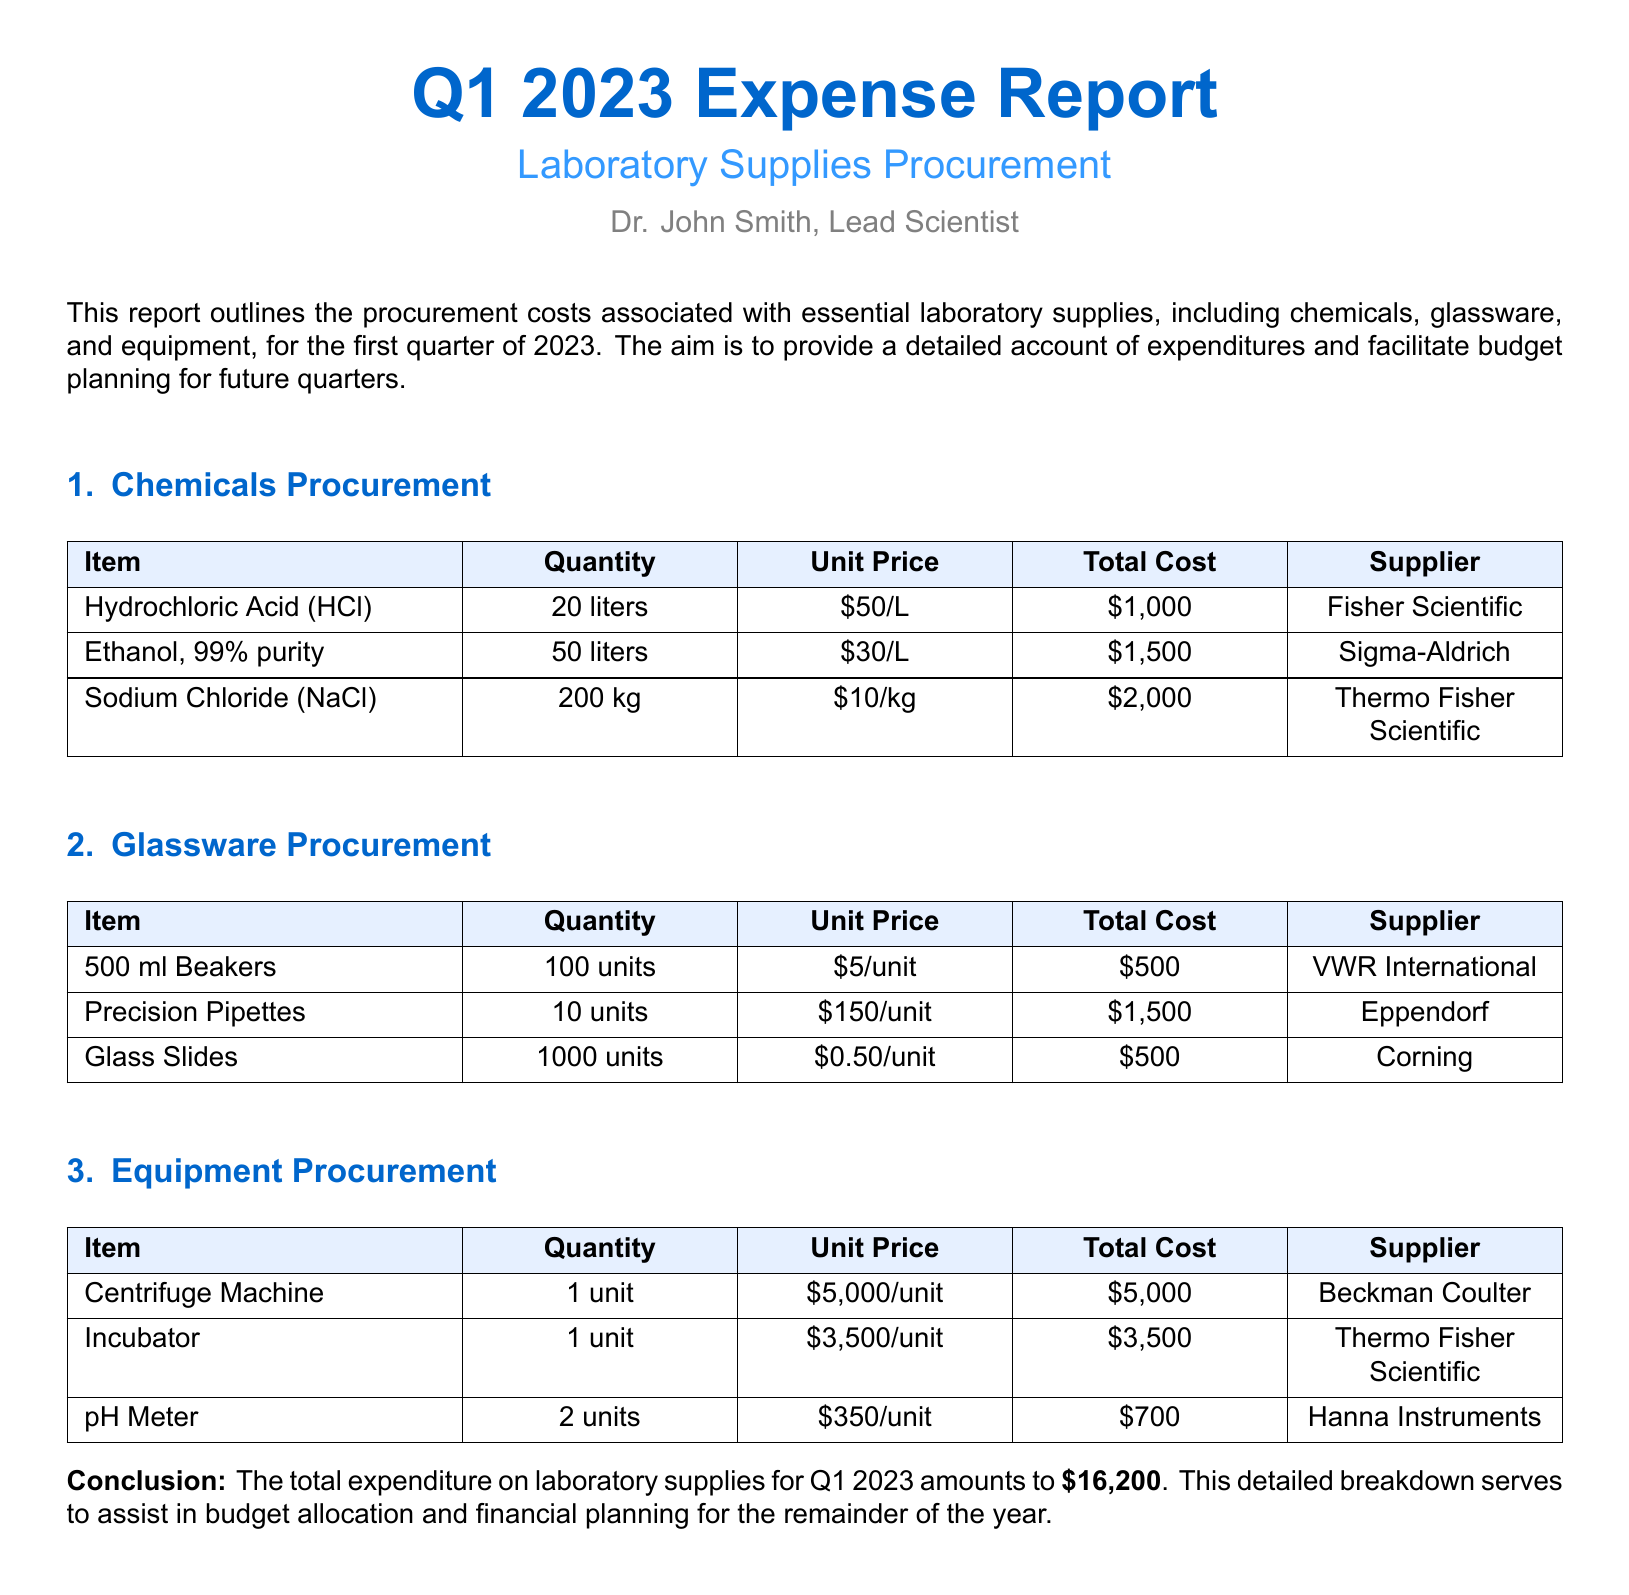What is the total expenditure for Q1 2023? The total expenditure is specifically mentioned at the end of the report, which is the sum of all supply costs listed throughout the document.
Answer: $16,200 What supplier provided Hydrochloric Acid? The report specifies the supplier for Hydrochloric Acid in the Chemicals Procurement section.
Answer: Fisher Scientific How many units of Precision Pipettes were procured? The document states the quantity of Precision Pipettes procured in the Glassware Procurement section.
Answer: 10 units What is the unit price of Sodium Chloride? The document lists the unit price for Sodium Chloride in the Chemicals Procurement section.
Answer: $10/kg Which equipment item cost the most? The report outlines the costs of each equipment item, allowing for comparison to identify the highest cost.
Answer: Centrifuge Machine How many liters of Ethanol were procured? The quantity of Ethanol procured is explicitly stated in the Chemicals Procurement section of the document.
Answer: 50 liters What is the total cost of glassware items? The total cost is derived from summing the costs of all glassware items listed in the Glassware Procurement section.
Answer: $2,500 What is the quantity of Glass Slides purchased? The report details the quantity for each glassware item, including Glass Slides, within its section.
Answer: 1000 units What type of document is this? The document is categorized under a specific financial reporting type focused on procurement expenses.
Answer: Expense report 